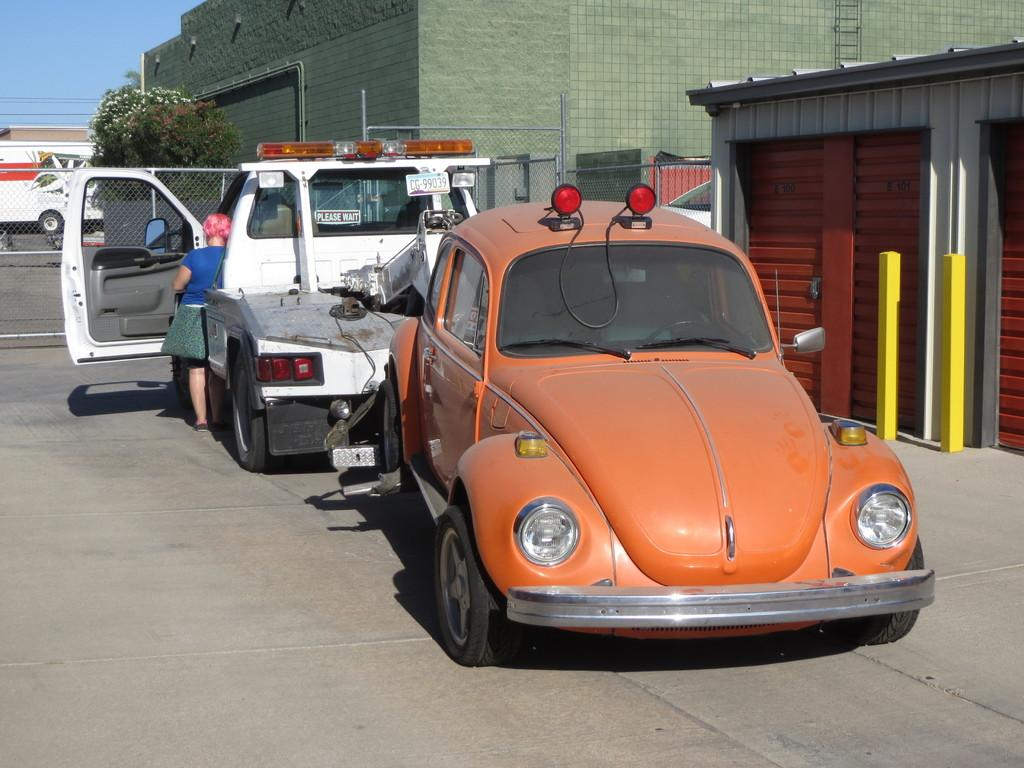What types of objects can be seen in the image? There are vehicles, trees, buildings, poles, and a fence in the image. Can you describe the natural elements in the image? There are trees in the image. What type of man-made structures are present in the image? There are buildings and poles in the image. What is visible in the background of the image? The sky is visible in the background of the image. What type of barrier can be seen in the image? There is a fence in the image. What type of flower is growing on the fence in the image? There are no flowers present in the image; it only features a fence. What is the profit margin of the vehicles in the image? There is no information about the profit margin of the vehicles in the image, as it only shows their presence. 